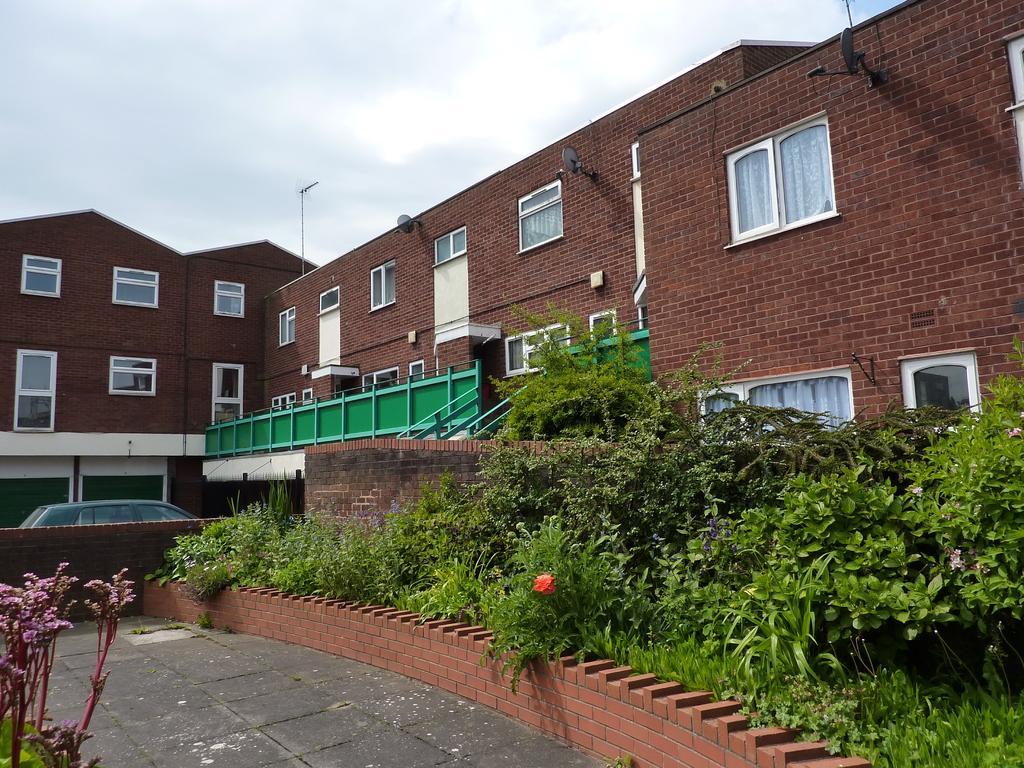Please provide a concise description of this image. In the photo there is a big building with many windows and doors from the balcony there is a way to get down,downside there are many plants in the entrance there is a car, in the back side there is a lawn. 